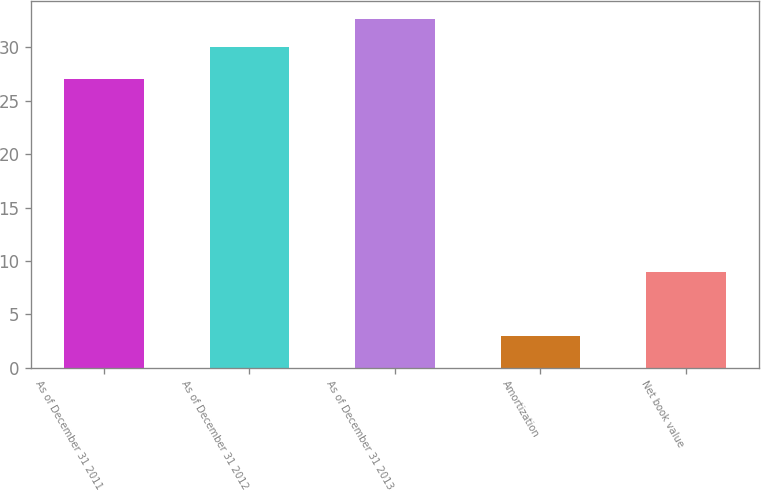Convert chart to OTSL. <chart><loc_0><loc_0><loc_500><loc_500><bar_chart><fcel>As of December 31 2011<fcel>As of December 31 2012<fcel>As of December 31 2013<fcel>Amortization<fcel>Net book value<nl><fcel>27<fcel>30<fcel>32.7<fcel>3<fcel>9<nl></chart> 